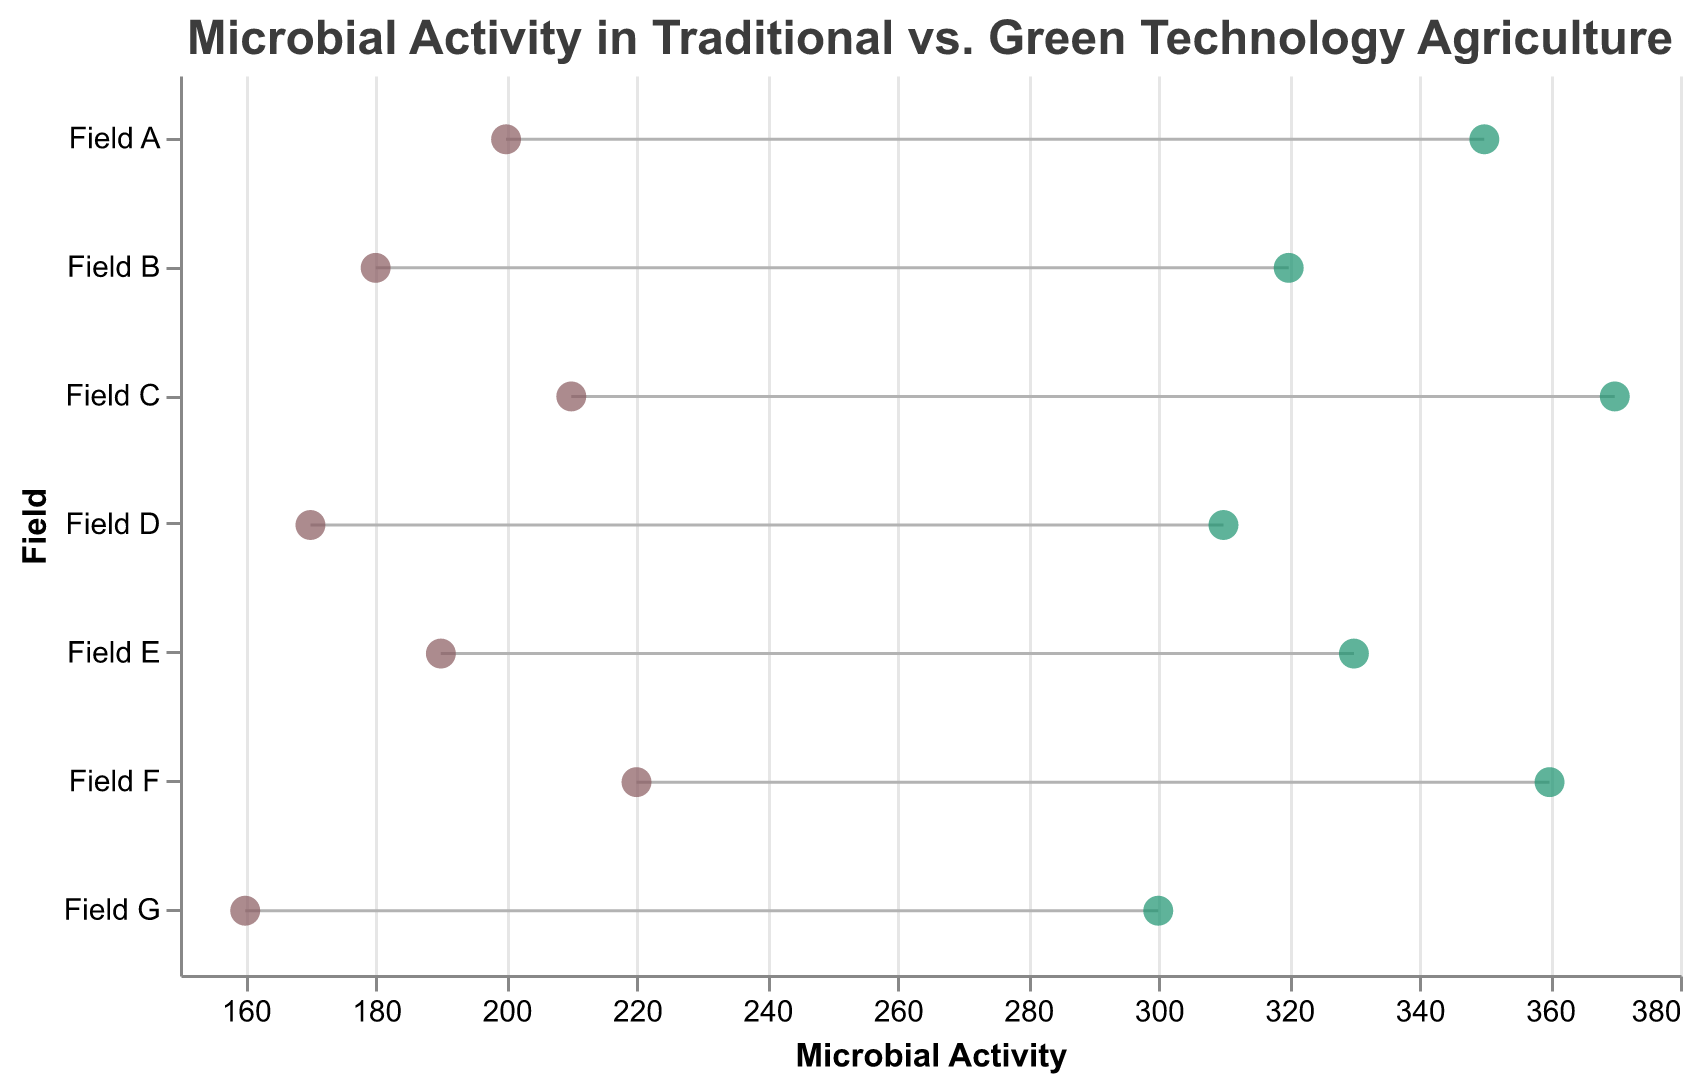Which field has the highest microbial activity in traditional agriculture? Looking at the data points on the left side of the plot, the field with the highest microbial activity is Field F with a value of 220.
Answer: Field F Which field has the lowest microbial activity in traditional agriculture? Based on the data points on the left side of the plot, the field with the lowest microbial activity is Field G with a value of 160.
Answer: Field G What is the difference in microbial activity between traditional and green technology in Field C? To find the difference, subtract the microbial activity of traditional agriculture from green technology for Field C. The difference is 370 - 210.
Answer: 160 How many fields show a higher microbial activity with green technology compared to traditional agriculture? By looking at the spacing between the left and right data points, it's evident that all fields (A to G) have higher microbial activity with green technology.
Answer: 7 What is the average microbial activity in green technology-supported fields? Summing up the microbial activity values in green technology (350 + 320 + 370 + 310 + 330 + 360 + 300) and dividing by the number of fields (7) gives the average value. This equals (350+320+370+310+330+360+300)/7.
Answer: 334 Are there any fields where the microbial activity exceeds 350 in green technology? By examining the green technology data points, Fields A, C, and F exceed 350.
Answer: Yes Which field shows the smallest increase in microbial activity when using green technology over traditional agriculture? Calculating the differences for each field and comparing them reveals that Field D shows the smallest increase: 310 - 170 = 140.
Answer: Field D What is the combined microbial activity for all fields using traditional agriculture? Adding the microbial activity values in the traditional agriculture column (200 + 180 + 210 + 170 + 190 + 220 + 160) results in a total of 1330.
Answer: 1330 Which field had the greatest increase in microbial activity when comparing traditional agriculture to green technology? Calculating the differences for each field and identifying the highest value indicates that Field C had the greatest increase of 160.
Answer: Field C 